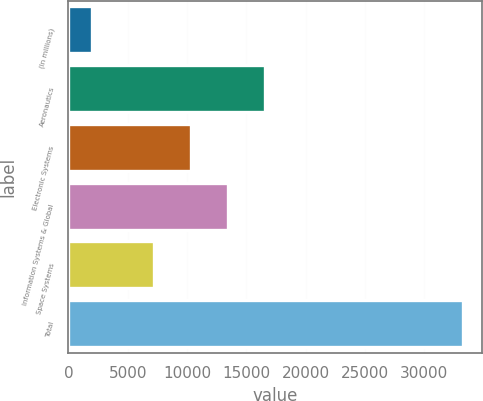Convert chart. <chart><loc_0><loc_0><loc_500><loc_500><bar_chart><fcel>(In millions)<fcel>Aeronautics<fcel>Electronic Systems<fcel>Information Systems & Global<fcel>Space Systems<fcel>Total<nl><fcel>2006<fcel>16559.1<fcel>10309.7<fcel>13434.4<fcel>7185<fcel>33253<nl></chart> 